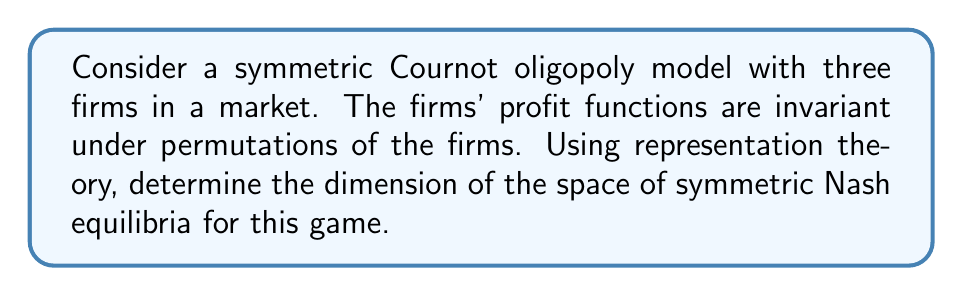Can you solve this math problem? 1. First, we identify the symmetry group of the game. In this case, it's the symmetric group $S_3$, which permutes the three firms.

2. The strategy space for each firm is $\mathbb{R}$, representing their output quantity. The total strategy space is thus $\mathbb{R}^3$.

3. The representation of $S_3$ on $\mathbb{R}^3$ decomposes into irreducible representations:

   $$\mathbb{R}^3 \cong V_{triv} \oplus V_{std}$$

   where $V_{triv}$ is the 1-dimensional trivial representation and $V_{std}$ is the 2-dimensional standard representation.

4. The symmetric Nash equilibria correspond to the fixed points of this action, which are precisely the elements of $V_{triv}$.

5. The dimension of $V_{triv}$ is 1, which represents strategies where all firms choose the same output.

6. Therefore, the space of symmetric Nash equilibria is 1-dimensional, corresponding to the line where all firms choose equal outputs.
Answer: 1 